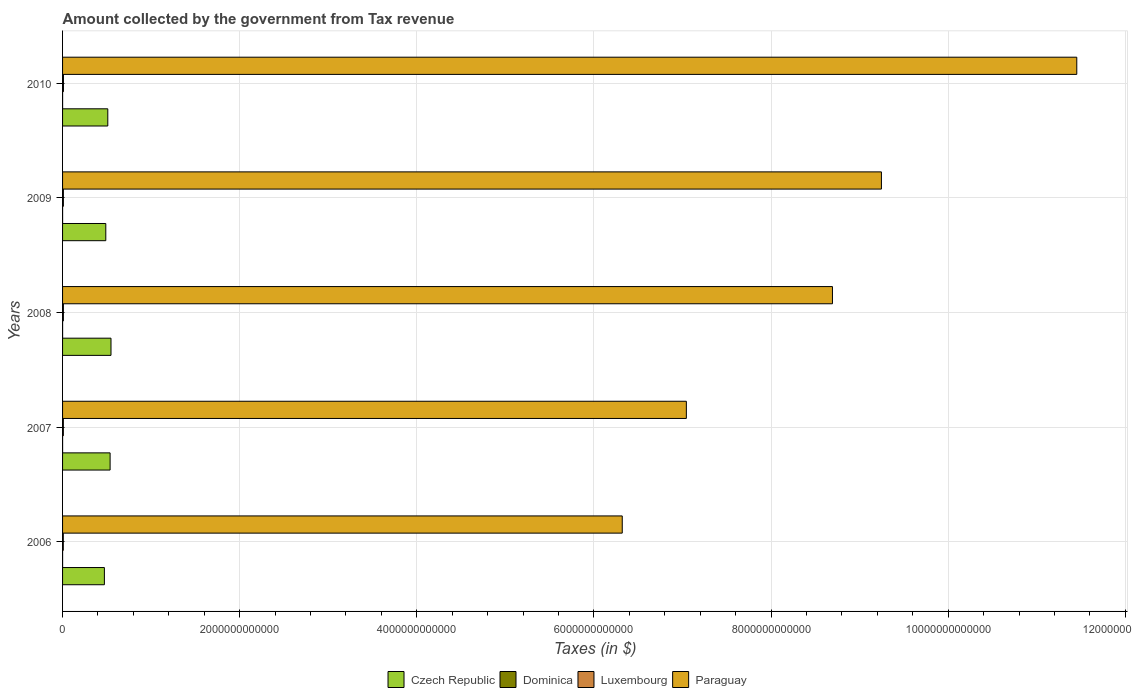Are the number of bars per tick equal to the number of legend labels?
Provide a succinct answer. Yes. How many bars are there on the 2nd tick from the top?
Make the answer very short. 4. What is the amount collected by the government from tax revenue in Czech Republic in 2008?
Offer a very short reply. 5.47e+11. Across all years, what is the maximum amount collected by the government from tax revenue in Paraguay?
Provide a succinct answer. 1.15e+13. Across all years, what is the minimum amount collected by the government from tax revenue in Dominica?
Make the answer very short. 2.48e+08. In which year was the amount collected by the government from tax revenue in Luxembourg minimum?
Your answer should be compact. 2006. What is the total amount collected by the government from tax revenue in Luxembourg in the graph?
Offer a very short reply. 4.57e+1. What is the difference between the amount collected by the government from tax revenue in Luxembourg in 2006 and that in 2007?
Offer a very short reply. -8.05e+08. What is the difference between the amount collected by the government from tax revenue in Luxembourg in 2008 and the amount collected by the government from tax revenue in Czech Republic in 2007?
Ensure brevity in your answer.  -5.27e+11. What is the average amount collected by the government from tax revenue in Dominica per year?
Keep it short and to the point. 2.98e+08. In the year 2007, what is the difference between the amount collected by the government from tax revenue in Czech Republic and amount collected by the government from tax revenue in Paraguay?
Your response must be concise. -6.51e+12. In how many years, is the amount collected by the government from tax revenue in Dominica greater than 11200000000000 $?
Provide a succinct answer. 0. What is the ratio of the amount collected by the government from tax revenue in Dominica in 2006 to that in 2010?
Your answer should be compact. 0.76. Is the amount collected by the government from tax revenue in Dominica in 2008 less than that in 2010?
Make the answer very short. Yes. What is the difference between the highest and the second highest amount collected by the government from tax revenue in Czech Republic?
Provide a short and direct response. 1.02e+1. What is the difference between the highest and the lowest amount collected by the government from tax revenue in Dominica?
Your answer should be very brief. 8.00e+07. What does the 3rd bar from the top in 2007 represents?
Offer a terse response. Dominica. What does the 1st bar from the bottom in 2007 represents?
Provide a succinct answer. Czech Republic. Is it the case that in every year, the sum of the amount collected by the government from tax revenue in Paraguay and amount collected by the government from tax revenue in Luxembourg is greater than the amount collected by the government from tax revenue in Dominica?
Give a very brief answer. Yes. Are all the bars in the graph horizontal?
Give a very brief answer. Yes. What is the difference between two consecutive major ticks on the X-axis?
Ensure brevity in your answer.  2.00e+12. Where does the legend appear in the graph?
Your answer should be very brief. Bottom center. What is the title of the graph?
Your answer should be compact. Amount collected by the government from Tax revenue. What is the label or title of the X-axis?
Give a very brief answer. Taxes (in $). What is the label or title of the Y-axis?
Offer a terse response. Years. What is the Taxes (in $) of Czech Republic in 2006?
Offer a very short reply. 4.72e+11. What is the Taxes (in $) of Dominica in 2006?
Offer a terse response. 2.48e+08. What is the Taxes (in $) of Luxembourg in 2006?
Offer a very short reply. 8.20e+09. What is the Taxes (in $) in Paraguay in 2006?
Provide a succinct answer. 6.32e+12. What is the Taxes (in $) of Czech Republic in 2007?
Provide a succinct answer. 5.37e+11. What is the Taxes (in $) in Dominica in 2007?
Keep it short and to the point. 2.86e+08. What is the Taxes (in $) in Luxembourg in 2007?
Your answer should be very brief. 9.00e+09. What is the Taxes (in $) of Paraguay in 2007?
Offer a very short reply. 7.04e+12. What is the Taxes (in $) of Czech Republic in 2008?
Offer a terse response. 5.47e+11. What is the Taxes (in $) of Dominica in 2008?
Ensure brevity in your answer.  3.07e+08. What is the Taxes (in $) in Luxembourg in 2008?
Provide a succinct answer. 9.34e+09. What is the Taxes (in $) in Paraguay in 2008?
Provide a short and direct response. 8.69e+12. What is the Taxes (in $) of Czech Republic in 2009?
Provide a succinct answer. 4.88e+11. What is the Taxes (in $) in Dominica in 2009?
Provide a short and direct response. 3.21e+08. What is the Taxes (in $) of Luxembourg in 2009?
Make the answer very short. 9.25e+09. What is the Taxes (in $) of Paraguay in 2009?
Ensure brevity in your answer.  9.25e+12. What is the Taxes (in $) of Czech Republic in 2010?
Offer a terse response. 5.11e+11. What is the Taxes (in $) in Dominica in 2010?
Ensure brevity in your answer.  3.28e+08. What is the Taxes (in $) in Luxembourg in 2010?
Give a very brief answer. 9.93e+09. What is the Taxes (in $) in Paraguay in 2010?
Your answer should be compact. 1.15e+13. Across all years, what is the maximum Taxes (in $) of Czech Republic?
Your answer should be compact. 5.47e+11. Across all years, what is the maximum Taxes (in $) in Dominica?
Your response must be concise. 3.28e+08. Across all years, what is the maximum Taxes (in $) in Luxembourg?
Your answer should be compact. 9.93e+09. Across all years, what is the maximum Taxes (in $) in Paraguay?
Offer a terse response. 1.15e+13. Across all years, what is the minimum Taxes (in $) in Czech Republic?
Your response must be concise. 4.72e+11. Across all years, what is the minimum Taxes (in $) of Dominica?
Keep it short and to the point. 2.48e+08. Across all years, what is the minimum Taxes (in $) in Luxembourg?
Give a very brief answer. 8.20e+09. Across all years, what is the minimum Taxes (in $) of Paraguay?
Provide a short and direct response. 6.32e+12. What is the total Taxes (in $) of Czech Republic in the graph?
Provide a short and direct response. 2.55e+12. What is the total Taxes (in $) in Dominica in the graph?
Provide a succinct answer. 1.49e+09. What is the total Taxes (in $) in Luxembourg in the graph?
Make the answer very short. 4.57e+1. What is the total Taxes (in $) in Paraguay in the graph?
Your answer should be compact. 4.28e+13. What is the difference between the Taxes (in $) in Czech Republic in 2006 and that in 2007?
Give a very brief answer. -6.45e+1. What is the difference between the Taxes (in $) in Dominica in 2006 and that in 2007?
Offer a very short reply. -3.76e+07. What is the difference between the Taxes (in $) in Luxembourg in 2006 and that in 2007?
Your answer should be compact. -8.05e+08. What is the difference between the Taxes (in $) of Paraguay in 2006 and that in 2007?
Your answer should be compact. -7.24e+11. What is the difference between the Taxes (in $) of Czech Republic in 2006 and that in 2008?
Your response must be concise. -7.47e+1. What is the difference between the Taxes (in $) of Dominica in 2006 and that in 2008?
Keep it short and to the point. -5.95e+07. What is the difference between the Taxes (in $) in Luxembourg in 2006 and that in 2008?
Your response must be concise. -1.15e+09. What is the difference between the Taxes (in $) in Paraguay in 2006 and that in 2008?
Your answer should be very brief. -2.37e+12. What is the difference between the Taxes (in $) of Czech Republic in 2006 and that in 2009?
Your answer should be very brief. -1.59e+1. What is the difference between the Taxes (in $) of Dominica in 2006 and that in 2009?
Your answer should be compact. -7.27e+07. What is the difference between the Taxes (in $) of Luxembourg in 2006 and that in 2009?
Provide a short and direct response. -1.05e+09. What is the difference between the Taxes (in $) of Paraguay in 2006 and that in 2009?
Give a very brief answer. -2.93e+12. What is the difference between the Taxes (in $) of Czech Republic in 2006 and that in 2010?
Keep it short and to the point. -3.85e+1. What is the difference between the Taxes (in $) in Dominica in 2006 and that in 2010?
Your answer should be very brief. -8.00e+07. What is the difference between the Taxes (in $) of Luxembourg in 2006 and that in 2010?
Ensure brevity in your answer.  -1.74e+09. What is the difference between the Taxes (in $) of Paraguay in 2006 and that in 2010?
Your answer should be very brief. -5.13e+12. What is the difference between the Taxes (in $) in Czech Republic in 2007 and that in 2008?
Offer a terse response. -1.02e+1. What is the difference between the Taxes (in $) of Dominica in 2007 and that in 2008?
Your response must be concise. -2.19e+07. What is the difference between the Taxes (in $) of Luxembourg in 2007 and that in 2008?
Offer a terse response. -3.40e+08. What is the difference between the Taxes (in $) of Paraguay in 2007 and that in 2008?
Provide a succinct answer. -1.65e+12. What is the difference between the Taxes (in $) in Czech Republic in 2007 and that in 2009?
Ensure brevity in your answer.  4.86e+1. What is the difference between the Taxes (in $) of Dominica in 2007 and that in 2009?
Make the answer very short. -3.51e+07. What is the difference between the Taxes (in $) of Luxembourg in 2007 and that in 2009?
Keep it short and to the point. -2.45e+08. What is the difference between the Taxes (in $) of Paraguay in 2007 and that in 2009?
Your answer should be compact. -2.20e+12. What is the difference between the Taxes (in $) of Czech Republic in 2007 and that in 2010?
Your answer should be very brief. 2.61e+1. What is the difference between the Taxes (in $) of Dominica in 2007 and that in 2010?
Your response must be concise. -4.24e+07. What is the difference between the Taxes (in $) of Luxembourg in 2007 and that in 2010?
Provide a succinct answer. -9.30e+08. What is the difference between the Taxes (in $) in Paraguay in 2007 and that in 2010?
Your answer should be very brief. -4.41e+12. What is the difference between the Taxes (in $) of Czech Republic in 2008 and that in 2009?
Provide a succinct answer. 5.88e+1. What is the difference between the Taxes (in $) of Dominica in 2008 and that in 2009?
Your answer should be compact. -1.32e+07. What is the difference between the Taxes (in $) in Luxembourg in 2008 and that in 2009?
Ensure brevity in your answer.  9.52e+07. What is the difference between the Taxes (in $) in Paraguay in 2008 and that in 2009?
Make the answer very short. -5.53e+11. What is the difference between the Taxes (in $) in Czech Republic in 2008 and that in 2010?
Your answer should be compact. 3.63e+1. What is the difference between the Taxes (in $) of Dominica in 2008 and that in 2010?
Offer a terse response. -2.05e+07. What is the difference between the Taxes (in $) in Luxembourg in 2008 and that in 2010?
Give a very brief answer. -5.90e+08. What is the difference between the Taxes (in $) in Paraguay in 2008 and that in 2010?
Provide a succinct answer. -2.76e+12. What is the difference between the Taxes (in $) in Czech Republic in 2009 and that in 2010?
Keep it short and to the point. -2.25e+1. What is the difference between the Taxes (in $) of Dominica in 2009 and that in 2010?
Your answer should be very brief. -7.30e+06. What is the difference between the Taxes (in $) in Luxembourg in 2009 and that in 2010?
Keep it short and to the point. -6.85e+08. What is the difference between the Taxes (in $) in Paraguay in 2009 and that in 2010?
Provide a short and direct response. -2.21e+12. What is the difference between the Taxes (in $) of Czech Republic in 2006 and the Taxes (in $) of Dominica in 2007?
Provide a short and direct response. 4.72e+11. What is the difference between the Taxes (in $) in Czech Republic in 2006 and the Taxes (in $) in Luxembourg in 2007?
Ensure brevity in your answer.  4.63e+11. What is the difference between the Taxes (in $) in Czech Republic in 2006 and the Taxes (in $) in Paraguay in 2007?
Ensure brevity in your answer.  -6.57e+12. What is the difference between the Taxes (in $) of Dominica in 2006 and the Taxes (in $) of Luxembourg in 2007?
Provide a succinct answer. -8.75e+09. What is the difference between the Taxes (in $) of Dominica in 2006 and the Taxes (in $) of Paraguay in 2007?
Your answer should be compact. -7.04e+12. What is the difference between the Taxes (in $) of Luxembourg in 2006 and the Taxes (in $) of Paraguay in 2007?
Your answer should be compact. -7.04e+12. What is the difference between the Taxes (in $) of Czech Republic in 2006 and the Taxes (in $) of Dominica in 2008?
Provide a short and direct response. 4.72e+11. What is the difference between the Taxes (in $) of Czech Republic in 2006 and the Taxes (in $) of Luxembourg in 2008?
Give a very brief answer. 4.63e+11. What is the difference between the Taxes (in $) of Czech Republic in 2006 and the Taxes (in $) of Paraguay in 2008?
Give a very brief answer. -8.22e+12. What is the difference between the Taxes (in $) of Dominica in 2006 and the Taxes (in $) of Luxembourg in 2008?
Give a very brief answer. -9.09e+09. What is the difference between the Taxes (in $) in Dominica in 2006 and the Taxes (in $) in Paraguay in 2008?
Keep it short and to the point. -8.69e+12. What is the difference between the Taxes (in $) of Luxembourg in 2006 and the Taxes (in $) of Paraguay in 2008?
Ensure brevity in your answer.  -8.69e+12. What is the difference between the Taxes (in $) in Czech Republic in 2006 and the Taxes (in $) in Dominica in 2009?
Provide a short and direct response. 4.72e+11. What is the difference between the Taxes (in $) of Czech Republic in 2006 and the Taxes (in $) of Luxembourg in 2009?
Your answer should be very brief. 4.63e+11. What is the difference between the Taxes (in $) of Czech Republic in 2006 and the Taxes (in $) of Paraguay in 2009?
Ensure brevity in your answer.  -8.77e+12. What is the difference between the Taxes (in $) of Dominica in 2006 and the Taxes (in $) of Luxembourg in 2009?
Provide a short and direct response. -9.00e+09. What is the difference between the Taxes (in $) of Dominica in 2006 and the Taxes (in $) of Paraguay in 2009?
Provide a succinct answer. -9.25e+12. What is the difference between the Taxes (in $) of Luxembourg in 2006 and the Taxes (in $) of Paraguay in 2009?
Your answer should be very brief. -9.24e+12. What is the difference between the Taxes (in $) in Czech Republic in 2006 and the Taxes (in $) in Dominica in 2010?
Offer a terse response. 4.72e+11. What is the difference between the Taxes (in $) of Czech Republic in 2006 and the Taxes (in $) of Luxembourg in 2010?
Provide a short and direct response. 4.62e+11. What is the difference between the Taxes (in $) in Czech Republic in 2006 and the Taxes (in $) in Paraguay in 2010?
Your response must be concise. -1.10e+13. What is the difference between the Taxes (in $) in Dominica in 2006 and the Taxes (in $) in Luxembourg in 2010?
Provide a short and direct response. -9.68e+09. What is the difference between the Taxes (in $) of Dominica in 2006 and the Taxes (in $) of Paraguay in 2010?
Keep it short and to the point. -1.15e+13. What is the difference between the Taxes (in $) of Luxembourg in 2006 and the Taxes (in $) of Paraguay in 2010?
Your answer should be very brief. -1.14e+13. What is the difference between the Taxes (in $) of Czech Republic in 2007 and the Taxes (in $) of Dominica in 2008?
Provide a succinct answer. 5.37e+11. What is the difference between the Taxes (in $) of Czech Republic in 2007 and the Taxes (in $) of Luxembourg in 2008?
Offer a very short reply. 5.27e+11. What is the difference between the Taxes (in $) in Czech Republic in 2007 and the Taxes (in $) in Paraguay in 2008?
Provide a succinct answer. -8.16e+12. What is the difference between the Taxes (in $) of Dominica in 2007 and the Taxes (in $) of Luxembourg in 2008?
Provide a short and direct response. -9.06e+09. What is the difference between the Taxes (in $) in Dominica in 2007 and the Taxes (in $) in Paraguay in 2008?
Offer a terse response. -8.69e+12. What is the difference between the Taxes (in $) in Luxembourg in 2007 and the Taxes (in $) in Paraguay in 2008?
Offer a very short reply. -8.68e+12. What is the difference between the Taxes (in $) in Czech Republic in 2007 and the Taxes (in $) in Dominica in 2009?
Your response must be concise. 5.36e+11. What is the difference between the Taxes (in $) of Czech Republic in 2007 and the Taxes (in $) of Luxembourg in 2009?
Keep it short and to the point. 5.28e+11. What is the difference between the Taxes (in $) of Czech Republic in 2007 and the Taxes (in $) of Paraguay in 2009?
Your response must be concise. -8.71e+12. What is the difference between the Taxes (in $) of Dominica in 2007 and the Taxes (in $) of Luxembourg in 2009?
Offer a terse response. -8.96e+09. What is the difference between the Taxes (in $) of Dominica in 2007 and the Taxes (in $) of Paraguay in 2009?
Make the answer very short. -9.25e+12. What is the difference between the Taxes (in $) of Luxembourg in 2007 and the Taxes (in $) of Paraguay in 2009?
Ensure brevity in your answer.  -9.24e+12. What is the difference between the Taxes (in $) in Czech Republic in 2007 and the Taxes (in $) in Dominica in 2010?
Give a very brief answer. 5.36e+11. What is the difference between the Taxes (in $) of Czech Republic in 2007 and the Taxes (in $) of Luxembourg in 2010?
Offer a terse response. 5.27e+11. What is the difference between the Taxes (in $) of Czech Republic in 2007 and the Taxes (in $) of Paraguay in 2010?
Your response must be concise. -1.09e+13. What is the difference between the Taxes (in $) of Dominica in 2007 and the Taxes (in $) of Luxembourg in 2010?
Make the answer very short. -9.65e+09. What is the difference between the Taxes (in $) of Dominica in 2007 and the Taxes (in $) of Paraguay in 2010?
Provide a short and direct response. -1.15e+13. What is the difference between the Taxes (in $) in Luxembourg in 2007 and the Taxes (in $) in Paraguay in 2010?
Provide a short and direct response. -1.14e+13. What is the difference between the Taxes (in $) in Czech Republic in 2008 and the Taxes (in $) in Dominica in 2009?
Your answer should be very brief. 5.47e+11. What is the difference between the Taxes (in $) of Czech Republic in 2008 and the Taxes (in $) of Luxembourg in 2009?
Provide a short and direct response. 5.38e+11. What is the difference between the Taxes (in $) of Czech Republic in 2008 and the Taxes (in $) of Paraguay in 2009?
Provide a succinct answer. -8.70e+12. What is the difference between the Taxes (in $) of Dominica in 2008 and the Taxes (in $) of Luxembourg in 2009?
Keep it short and to the point. -8.94e+09. What is the difference between the Taxes (in $) of Dominica in 2008 and the Taxes (in $) of Paraguay in 2009?
Offer a very short reply. -9.25e+12. What is the difference between the Taxes (in $) of Luxembourg in 2008 and the Taxes (in $) of Paraguay in 2009?
Your response must be concise. -9.24e+12. What is the difference between the Taxes (in $) in Czech Republic in 2008 and the Taxes (in $) in Dominica in 2010?
Provide a short and direct response. 5.47e+11. What is the difference between the Taxes (in $) in Czech Republic in 2008 and the Taxes (in $) in Luxembourg in 2010?
Offer a terse response. 5.37e+11. What is the difference between the Taxes (in $) in Czech Republic in 2008 and the Taxes (in $) in Paraguay in 2010?
Ensure brevity in your answer.  -1.09e+13. What is the difference between the Taxes (in $) of Dominica in 2008 and the Taxes (in $) of Luxembourg in 2010?
Make the answer very short. -9.62e+09. What is the difference between the Taxes (in $) in Dominica in 2008 and the Taxes (in $) in Paraguay in 2010?
Keep it short and to the point. -1.15e+13. What is the difference between the Taxes (in $) of Luxembourg in 2008 and the Taxes (in $) of Paraguay in 2010?
Ensure brevity in your answer.  -1.14e+13. What is the difference between the Taxes (in $) of Czech Republic in 2009 and the Taxes (in $) of Dominica in 2010?
Offer a terse response. 4.88e+11. What is the difference between the Taxes (in $) in Czech Republic in 2009 and the Taxes (in $) in Luxembourg in 2010?
Keep it short and to the point. 4.78e+11. What is the difference between the Taxes (in $) of Czech Republic in 2009 and the Taxes (in $) of Paraguay in 2010?
Make the answer very short. -1.10e+13. What is the difference between the Taxes (in $) in Dominica in 2009 and the Taxes (in $) in Luxembourg in 2010?
Provide a succinct answer. -9.61e+09. What is the difference between the Taxes (in $) in Dominica in 2009 and the Taxes (in $) in Paraguay in 2010?
Offer a terse response. -1.15e+13. What is the difference between the Taxes (in $) of Luxembourg in 2009 and the Taxes (in $) of Paraguay in 2010?
Your response must be concise. -1.14e+13. What is the average Taxes (in $) in Czech Republic per year?
Make the answer very short. 5.11e+11. What is the average Taxes (in $) in Dominica per year?
Provide a succinct answer. 2.98e+08. What is the average Taxes (in $) in Luxembourg per year?
Keep it short and to the point. 9.14e+09. What is the average Taxes (in $) of Paraguay per year?
Your response must be concise. 8.55e+12. In the year 2006, what is the difference between the Taxes (in $) in Czech Republic and Taxes (in $) in Dominica?
Offer a very short reply. 4.72e+11. In the year 2006, what is the difference between the Taxes (in $) in Czech Republic and Taxes (in $) in Luxembourg?
Offer a very short reply. 4.64e+11. In the year 2006, what is the difference between the Taxes (in $) in Czech Republic and Taxes (in $) in Paraguay?
Ensure brevity in your answer.  -5.85e+12. In the year 2006, what is the difference between the Taxes (in $) in Dominica and Taxes (in $) in Luxembourg?
Ensure brevity in your answer.  -7.95e+09. In the year 2006, what is the difference between the Taxes (in $) of Dominica and Taxes (in $) of Paraguay?
Offer a terse response. -6.32e+12. In the year 2006, what is the difference between the Taxes (in $) of Luxembourg and Taxes (in $) of Paraguay?
Make the answer very short. -6.31e+12. In the year 2007, what is the difference between the Taxes (in $) in Czech Republic and Taxes (in $) in Dominica?
Your response must be concise. 5.37e+11. In the year 2007, what is the difference between the Taxes (in $) of Czech Republic and Taxes (in $) of Luxembourg?
Ensure brevity in your answer.  5.28e+11. In the year 2007, what is the difference between the Taxes (in $) of Czech Republic and Taxes (in $) of Paraguay?
Provide a succinct answer. -6.51e+12. In the year 2007, what is the difference between the Taxes (in $) of Dominica and Taxes (in $) of Luxembourg?
Your answer should be very brief. -8.72e+09. In the year 2007, what is the difference between the Taxes (in $) in Dominica and Taxes (in $) in Paraguay?
Your response must be concise. -7.04e+12. In the year 2007, what is the difference between the Taxes (in $) of Luxembourg and Taxes (in $) of Paraguay?
Offer a very short reply. -7.03e+12. In the year 2008, what is the difference between the Taxes (in $) of Czech Republic and Taxes (in $) of Dominica?
Make the answer very short. 5.47e+11. In the year 2008, what is the difference between the Taxes (in $) in Czech Republic and Taxes (in $) in Luxembourg?
Ensure brevity in your answer.  5.38e+11. In the year 2008, what is the difference between the Taxes (in $) of Czech Republic and Taxes (in $) of Paraguay?
Your answer should be very brief. -8.15e+12. In the year 2008, what is the difference between the Taxes (in $) of Dominica and Taxes (in $) of Luxembourg?
Your answer should be compact. -9.03e+09. In the year 2008, what is the difference between the Taxes (in $) in Dominica and Taxes (in $) in Paraguay?
Ensure brevity in your answer.  -8.69e+12. In the year 2008, what is the difference between the Taxes (in $) in Luxembourg and Taxes (in $) in Paraguay?
Offer a very short reply. -8.68e+12. In the year 2009, what is the difference between the Taxes (in $) in Czech Republic and Taxes (in $) in Dominica?
Make the answer very short. 4.88e+11. In the year 2009, what is the difference between the Taxes (in $) of Czech Republic and Taxes (in $) of Luxembourg?
Ensure brevity in your answer.  4.79e+11. In the year 2009, what is the difference between the Taxes (in $) in Czech Republic and Taxes (in $) in Paraguay?
Make the answer very short. -8.76e+12. In the year 2009, what is the difference between the Taxes (in $) of Dominica and Taxes (in $) of Luxembourg?
Provide a succinct answer. -8.93e+09. In the year 2009, what is the difference between the Taxes (in $) of Dominica and Taxes (in $) of Paraguay?
Offer a terse response. -9.25e+12. In the year 2009, what is the difference between the Taxes (in $) of Luxembourg and Taxes (in $) of Paraguay?
Keep it short and to the point. -9.24e+12. In the year 2010, what is the difference between the Taxes (in $) of Czech Republic and Taxes (in $) of Dominica?
Your answer should be compact. 5.10e+11. In the year 2010, what is the difference between the Taxes (in $) in Czech Republic and Taxes (in $) in Luxembourg?
Make the answer very short. 5.01e+11. In the year 2010, what is the difference between the Taxes (in $) in Czech Republic and Taxes (in $) in Paraguay?
Your answer should be very brief. -1.09e+13. In the year 2010, what is the difference between the Taxes (in $) in Dominica and Taxes (in $) in Luxembourg?
Your response must be concise. -9.60e+09. In the year 2010, what is the difference between the Taxes (in $) of Dominica and Taxes (in $) of Paraguay?
Ensure brevity in your answer.  -1.15e+13. In the year 2010, what is the difference between the Taxes (in $) in Luxembourg and Taxes (in $) in Paraguay?
Your answer should be very brief. -1.14e+13. What is the ratio of the Taxes (in $) in Czech Republic in 2006 to that in 2007?
Make the answer very short. 0.88. What is the ratio of the Taxes (in $) in Dominica in 2006 to that in 2007?
Ensure brevity in your answer.  0.87. What is the ratio of the Taxes (in $) in Luxembourg in 2006 to that in 2007?
Offer a terse response. 0.91. What is the ratio of the Taxes (in $) in Paraguay in 2006 to that in 2007?
Provide a succinct answer. 0.9. What is the ratio of the Taxes (in $) in Czech Republic in 2006 to that in 2008?
Keep it short and to the point. 0.86. What is the ratio of the Taxes (in $) in Dominica in 2006 to that in 2008?
Give a very brief answer. 0.81. What is the ratio of the Taxes (in $) in Luxembourg in 2006 to that in 2008?
Ensure brevity in your answer.  0.88. What is the ratio of the Taxes (in $) in Paraguay in 2006 to that in 2008?
Your answer should be compact. 0.73. What is the ratio of the Taxes (in $) of Czech Republic in 2006 to that in 2009?
Give a very brief answer. 0.97. What is the ratio of the Taxes (in $) of Dominica in 2006 to that in 2009?
Your answer should be very brief. 0.77. What is the ratio of the Taxes (in $) in Luxembourg in 2006 to that in 2009?
Your response must be concise. 0.89. What is the ratio of the Taxes (in $) in Paraguay in 2006 to that in 2009?
Give a very brief answer. 0.68. What is the ratio of the Taxes (in $) of Czech Republic in 2006 to that in 2010?
Offer a very short reply. 0.92. What is the ratio of the Taxes (in $) of Dominica in 2006 to that in 2010?
Keep it short and to the point. 0.76. What is the ratio of the Taxes (in $) in Luxembourg in 2006 to that in 2010?
Make the answer very short. 0.83. What is the ratio of the Taxes (in $) in Paraguay in 2006 to that in 2010?
Make the answer very short. 0.55. What is the ratio of the Taxes (in $) of Czech Republic in 2007 to that in 2008?
Your answer should be compact. 0.98. What is the ratio of the Taxes (in $) of Dominica in 2007 to that in 2008?
Offer a terse response. 0.93. What is the ratio of the Taxes (in $) of Luxembourg in 2007 to that in 2008?
Ensure brevity in your answer.  0.96. What is the ratio of the Taxes (in $) of Paraguay in 2007 to that in 2008?
Your answer should be compact. 0.81. What is the ratio of the Taxes (in $) of Czech Republic in 2007 to that in 2009?
Give a very brief answer. 1.1. What is the ratio of the Taxes (in $) in Dominica in 2007 to that in 2009?
Offer a terse response. 0.89. What is the ratio of the Taxes (in $) of Luxembourg in 2007 to that in 2009?
Your answer should be very brief. 0.97. What is the ratio of the Taxes (in $) in Paraguay in 2007 to that in 2009?
Offer a terse response. 0.76. What is the ratio of the Taxes (in $) of Czech Republic in 2007 to that in 2010?
Keep it short and to the point. 1.05. What is the ratio of the Taxes (in $) in Dominica in 2007 to that in 2010?
Your answer should be very brief. 0.87. What is the ratio of the Taxes (in $) of Luxembourg in 2007 to that in 2010?
Provide a short and direct response. 0.91. What is the ratio of the Taxes (in $) in Paraguay in 2007 to that in 2010?
Provide a short and direct response. 0.61. What is the ratio of the Taxes (in $) of Czech Republic in 2008 to that in 2009?
Keep it short and to the point. 1.12. What is the ratio of the Taxes (in $) of Dominica in 2008 to that in 2009?
Offer a very short reply. 0.96. What is the ratio of the Taxes (in $) in Luxembourg in 2008 to that in 2009?
Give a very brief answer. 1.01. What is the ratio of the Taxes (in $) of Paraguay in 2008 to that in 2009?
Your response must be concise. 0.94. What is the ratio of the Taxes (in $) in Czech Republic in 2008 to that in 2010?
Provide a succinct answer. 1.07. What is the ratio of the Taxes (in $) of Dominica in 2008 to that in 2010?
Give a very brief answer. 0.94. What is the ratio of the Taxes (in $) in Luxembourg in 2008 to that in 2010?
Keep it short and to the point. 0.94. What is the ratio of the Taxes (in $) of Paraguay in 2008 to that in 2010?
Provide a short and direct response. 0.76. What is the ratio of the Taxes (in $) of Czech Republic in 2009 to that in 2010?
Your response must be concise. 0.96. What is the ratio of the Taxes (in $) of Dominica in 2009 to that in 2010?
Offer a terse response. 0.98. What is the ratio of the Taxes (in $) of Luxembourg in 2009 to that in 2010?
Offer a very short reply. 0.93. What is the ratio of the Taxes (in $) of Paraguay in 2009 to that in 2010?
Offer a very short reply. 0.81. What is the difference between the highest and the second highest Taxes (in $) in Czech Republic?
Ensure brevity in your answer.  1.02e+1. What is the difference between the highest and the second highest Taxes (in $) of Dominica?
Make the answer very short. 7.30e+06. What is the difference between the highest and the second highest Taxes (in $) in Luxembourg?
Your response must be concise. 5.90e+08. What is the difference between the highest and the second highest Taxes (in $) in Paraguay?
Make the answer very short. 2.21e+12. What is the difference between the highest and the lowest Taxes (in $) of Czech Republic?
Your response must be concise. 7.47e+1. What is the difference between the highest and the lowest Taxes (in $) in Dominica?
Offer a terse response. 8.00e+07. What is the difference between the highest and the lowest Taxes (in $) in Luxembourg?
Keep it short and to the point. 1.74e+09. What is the difference between the highest and the lowest Taxes (in $) in Paraguay?
Keep it short and to the point. 5.13e+12. 